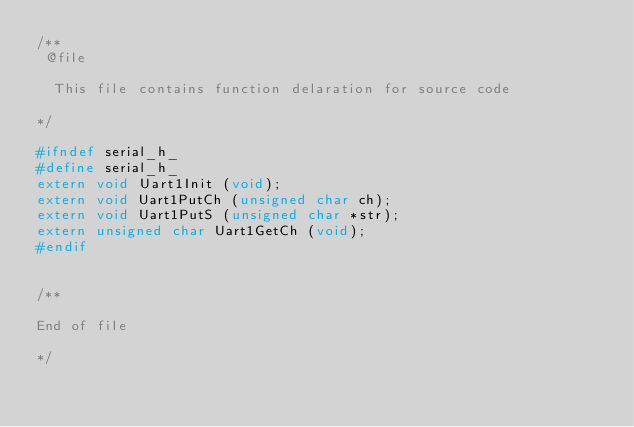Convert code to text. <code><loc_0><loc_0><loc_500><loc_500><_C_>/**
 @file
 
 	This file contains function delaration for source code
 	
*/

#ifndef serial_h_
#define serial_h_
extern void Uart1Init (void);
extern void Uart1PutCh (unsigned char ch);
extern void Uart1PutS (unsigned char *str);
extern unsigned char Uart1GetCh (void);
#endif 


/**

End of file

*/
</code> 